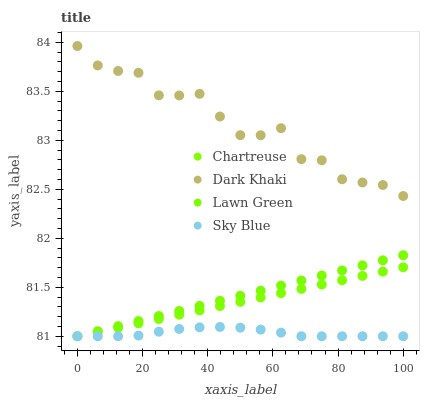Does Sky Blue have the minimum area under the curve?
Answer yes or no. Yes. Does Dark Khaki have the maximum area under the curve?
Answer yes or no. Yes. Does Lawn Green have the minimum area under the curve?
Answer yes or no. No. Does Lawn Green have the maximum area under the curve?
Answer yes or no. No. Is Chartreuse the smoothest?
Answer yes or no. Yes. Is Dark Khaki the roughest?
Answer yes or no. Yes. Is Lawn Green the smoothest?
Answer yes or no. No. Is Lawn Green the roughest?
Answer yes or no. No. Does Lawn Green have the lowest value?
Answer yes or no. Yes. Does Dark Khaki have the highest value?
Answer yes or no. Yes. Does Lawn Green have the highest value?
Answer yes or no. No. Is Chartreuse less than Dark Khaki?
Answer yes or no. Yes. Is Dark Khaki greater than Chartreuse?
Answer yes or no. Yes. Does Chartreuse intersect Lawn Green?
Answer yes or no. Yes. Is Chartreuse less than Lawn Green?
Answer yes or no. No. Is Chartreuse greater than Lawn Green?
Answer yes or no. No. Does Chartreuse intersect Dark Khaki?
Answer yes or no. No. 